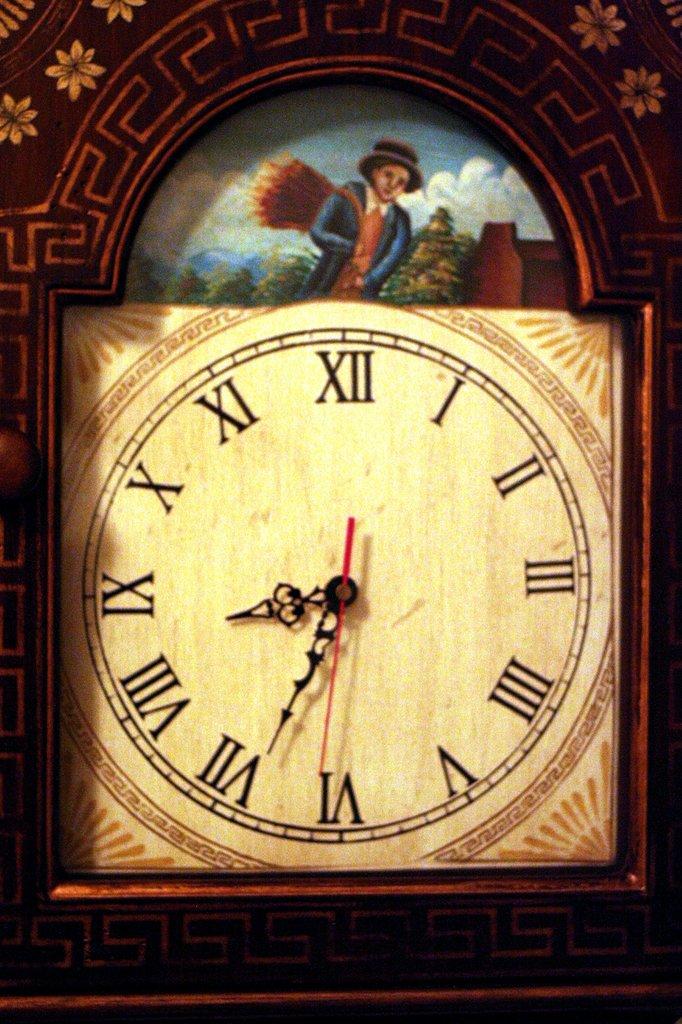What time does the clock say?
Your response must be concise. 8:34. 